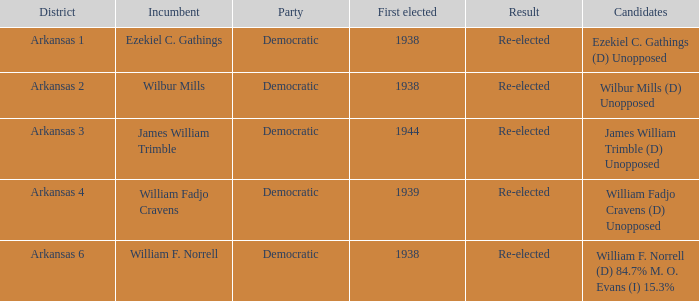In how many districts was william f. norrell the incumbent? 1.0. 